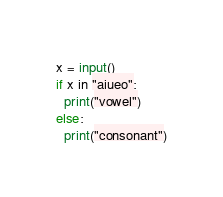<code> <loc_0><loc_0><loc_500><loc_500><_Python_>x = input()
if x in "aiueo":
  print("vowel")
else:
  print("consonant")</code> 